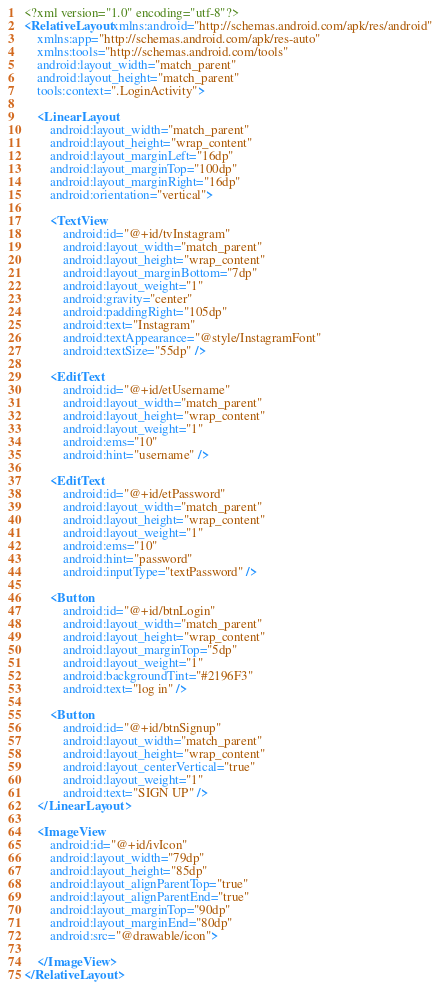Convert code to text. <code><loc_0><loc_0><loc_500><loc_500><_XML_><?xml version="1.0" encoding="utf-8"?>
<RelativeLayout xmlns:android="http://schemas.android.com/apk/res/android"
    xmlns:app="http://schemas.android.com/apk/res-auto"
    xmlns:tools="http://schemas.android.com/tools"
    android:layout_width="match_parent"
    android:layout_height="match_parent"
    tools:context=".LoginActivity">

    <LinearLayout
        android:layout_width="match_parent"
        android:layout_height="wrap_content"
        android:layout_marginLeft="16dp"
        android:layout_marginTop="100dp"
        android:layout_marginRight="16dp"
        android:orientation="vertical">

        <TextView
            android:id="@+id/tvInstagram"
            android:layout_width="match_parent"
            android:layout_height="wrap_content"
            android:layout_marginBottom="7dp"
            android:layout_weight="1"
            android:gravity="center"
            android:paddingRight="105dp"
            android:text="Instagram"
            android:textAppearance="@style/InstagramFont"
            android:textSize="55dp" />

        <EditText
            android:id="@+id/etUsername"
            android:layout_width="match_parent"
            android:layout_height="wrap_content"
            android:layout_weight="1"
            android:ems="10"
            android:hint="username" />

        <EditText
            android:id="@+id/etPassword"
            android:layout_width="match_parent"
            android:layout_height="wrap_content"
            android:layout_weight="1"
            android:ems="10"
            android:hint="password"
            android:inputType="textPassword" />

        <Button
            android:id="@+id/btnLogin"
            android:layout_width="match_parent"
            android:layout_height="wrap_content"
            android:layout_marginTop="5dp"
            android:layout_weight="1"
            android:backgroundTint="#2196F3"
            android:text="log in" />

        <Button
            android:id="@+id/btnSignup"
            android:layout_width="match_parent"
            android:layout_height="wrap_content"
            android:layout_centerVertical="true"
            android:layout_weight="1"
            android:text="SIGN UP" />
    </LinearLayout>

    <ImageView
        android:id="@+id/ivIcon"
        android:layout_width="79dp"
        android:layout_height="85dp"
        android:layout_alignParentTop="true"
        android:layout_alignParentEnd="true"
        android:layout_marginTop="90dp"
        android:layout_marginEnd="80dp"
        android:src="@drawable/icon">

    </ImageView>
</RelativeLayout></code> 